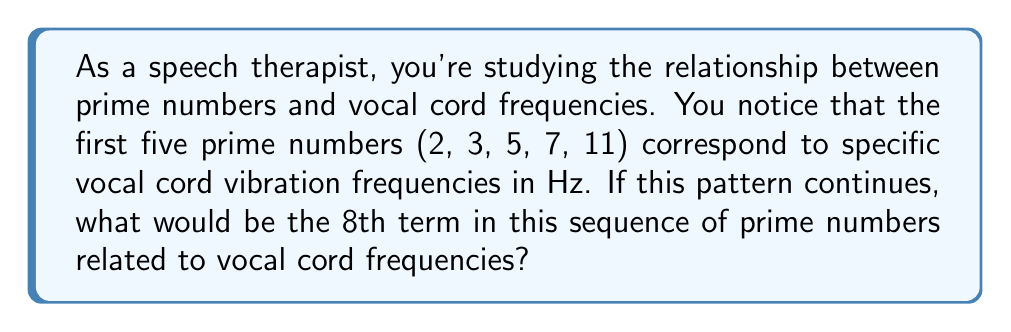Provide a solution to this math problem. Let's approach this step-by-step:

1) First, let's list out the first 8 prime numbers:
   2, 3, 5, 7, 11, 13, 17, 19

2) We're told that the first 5 prime numbers correspond to specific vocal cord frequencies. We need to find the 8th term in this sequence.

3) To do this, we need to understand the pattern of prime numbers. Each prime number is the smallest positive integer greater than 1 that is only divisible by 1 and itself.

4) The difference between consecutive prime numbers is not constant. Let's calculate the differences:

   3 - 2 = 1
   5 - 3 = 2
   7 - 5 = 2
   11 - 7 = 4
   13 - 11 = 2
   17 - 13 = 4
   19 - 17 = 2

5) There's no discernible pattern in these differences, which is characteristic of prime numbers.

6) Therefore, the 8th term in this sequence would simply be the 8th prime number, which is 19.

This means that if the pattern of prime numbers corresponding to vocal cord frequencies continues, the 8th frequency in this sequence would correspond to the prime number 19 Hz.
Answer: 19 